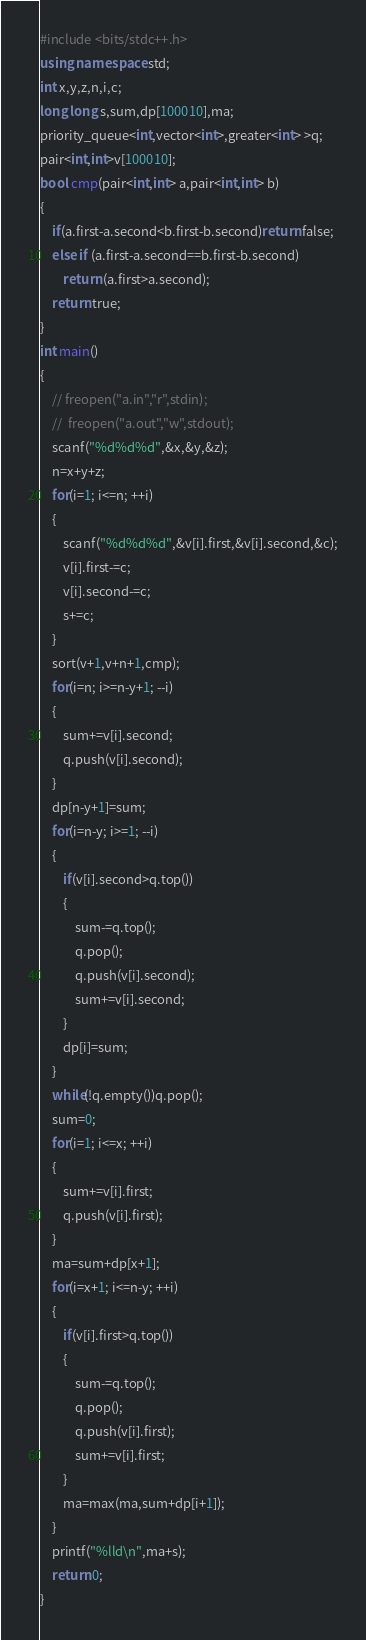<code> <loc_0><loc_0><loc_500><loc_500><_C++_>#include <bits/stdc++.h>
using namespace std;
int x,y,z,n,i,c;
long long s,sum,dp[100010],ma;
priority_queue<int,vector<int>,greater<int> >q;
pair<int,int>v[100010];
bool cmp(pair<int,int> a,pair<int,int> b)
{
    if(a.first-a.second<b.first-b.second)return false;
    else if (a.first-a.second==b.first-b.second)
        return (a.first>a.second);
    return true;
}
int main()
{
    // freopen("a.in","r",stdin);
    //  freopen("a.out","w",stdout);
    scanf("%d%d%d",&x,&y,&z);
    n=x+y+z;
    for(i=1; i<=n; ++i)
    {
        scanf("%d%d%d",&v[i].first,&v[i].second,&c);
        v[i].first-=c;
        v[i].second-=c;
        s+=c;
    }
    sort(v+1,v+n+1,cmp);
    for(i=n; i>=n-y+1; --i)
    {
        sum+=v[i].second;
        q.push(v[i].second);
    }
    dp[n-y+1]=sum;
    for(i=n-y; i>=1; --i)
    {
        if(v[i].second>q.top())
        {
            sum-=q.top();
            q.pop();
            q.push(v[i].second);
            sum+=v[i].second;
        }
        dp[i]=sum;
    }
    while(!q.empty())q.pop();
    sum=0;
    for(i=1; i<=x; ++i)
    {
        sum+=v[i].first;
        q.push(v[i].first);
    }
    ma=sum+dp[x+1];
    for(i=x+1; i<=n-y; ++i)
    {
        if(v[i].first>q.top())
        {
            sum-=q.top();
            q.pop();
            q.push(v[i].first);
            sum+=v[i].first;
        }
        ma=max(ma,sum+dp[i+1]);
    }
    printf("%lld\n",ma+s);
    return 0;
}
</code> 